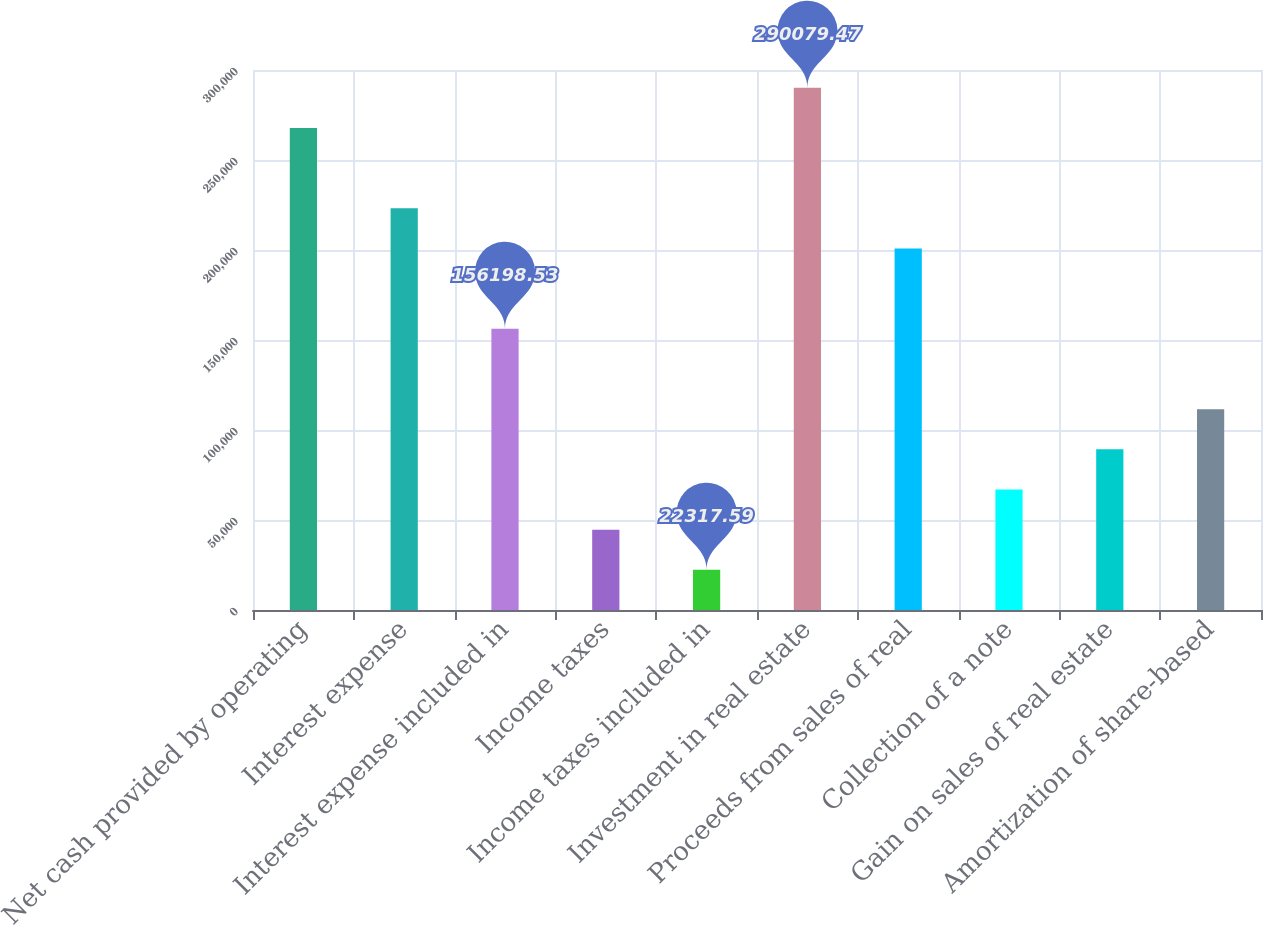Convert chart. <chart><loc_0><loc_0><loc_500><loc_500><bar_chart><fcel>Net cash provided by operating<fcel>Interest expense<fcel>Interest expense included in<fcel>Income taxes<fcel>Income taxes included in<fcel>Investment in real estate<fcel>Proceeds from sales of real<fcel>Collection of a note<fcel>Gain on sales of real estate<fcel>Amortization of share-based<nl><fcel>267766<fcel>223139<fcel>156199<fcel>44631.1<fcel>22317.6<fcel>290079<fcel>200826<fcel>66944.6<fcel>89258.1<fcel>111572<nl></chart> 